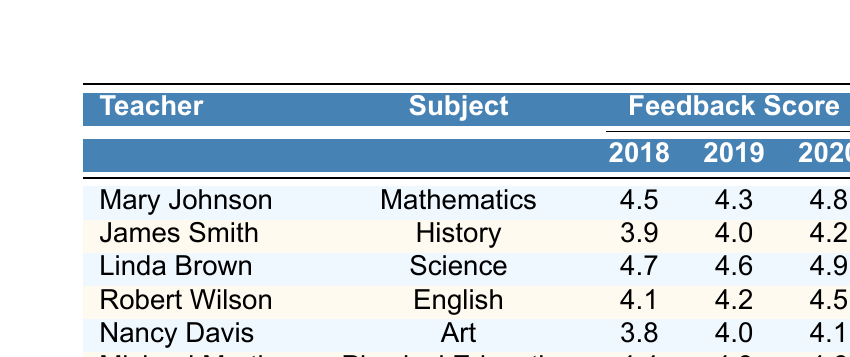What was the feedback score for Mary Johnson in 2019? In the row for Mary Johnson under the year 2019, the feedback score is listed as 4.3.
Answer: 4.3 Which teacher had the highest feedback score in 2020? Looking at the 2020 column, Mary Johnson has a score of 4.8, Linda Brown has 4.9, Robert Wilson has 4.5, Nancy Davis has 4.1, and Michael Martinez has 4.6. The highest score is 4.9 for Linda Brown.
Answer: Linda Brown What is the difference between Robert Wilson's 2018 and 2020 feedback scores? Robert Wilson's 2018 score is 4.1 and his 2020 score is 4.5. The difference is 4.5 - 4.1 = 0.4.
Answer: 0.4 What is the average feedback score for James Smith over the three years? The total scores for James Smith are 3.9 (2018) + 4.0 (2019) + 4.2 (2020) = 12.1. There are three years, so the average is 12.1 / 3 = 4.03333, which rounds to about 4.03.
Answer: 4.03 Did Nancy Davis receive a feedback score of 4.0 or higher in all three years? Nancy Davis's scores are 3.8 (2018), 4.0 (2019), and 4.1 (2020). She did not receive 4.0 or higher in 2018 and therefore does not meet the condition.
Answer: No Which subject had the highest average feedback score across all years? Calculating the averages: Mathematics (4.5 + 4.3 + 4.8)/3 = 4.53333, History (3.9 + 4.0 + 4.2)/3 = 4.03333, Science (4.7 + 4.6 + 4.9)/3 = 4.73333, English (4.1 + 4.2 + 4.5)/3 = 4.26667, Art (3.8 + 4.0 + 4.1)/3 = 3.96667, Physical Education (4.4 + 4.3 + 4.6)/3 = 4.43333. The highest average is 4.73333 for Science.
Answer: Science Whose feedback scores showed an increasing trend over the years? Analyzing each teacher's scores: Mary Johnson went from 4.5 to 4.3 to 4.8 (not increasing), James Smith went from 3.9 to 4.0 to 4.2 (increasing), Linda Brown went from 4.7 to 4.6 to 4.9 (not consistently increasing), Robert Wilson went from 4.1 to 4.2 to 4.5 (increasing), Nancy Davis went from 3.8 to 4.0 to 4.1 (increasing), and Michael Martinez went from 4.4 to 4.3 to 4.6 (not consistently increasing). Thus, James Smith, Robert Wilson, and Nancy Davis had increasing scores.
Answer: James Smith, Robert Wilson, Nancy Davis In which year did Michael Martinez have the lowest feedback score? Michael Martinez's scores are 4.4 (2018), 4.3 (2019), and 4.6 (2020). The lowest score was in 2019 with 4.3.
Answer: 2019 What was the total feedback score for all teachers in 2018? Summing the scores for 2018: Mary Johnson (4.5) + James Smith (3.9) + Linda Brown (4.7) + Robert Wilson (4.1) + Nancy Davis (3.8) + Michael Martinez (4.4) gives 4.5 + 3.9 + 4.7 + 4.1 + 3.8 + 4.4 = 25.4.
Answer: 25.4 Was Linda Brown always rated higher than Robert Wilson? Comparing scores across all years: 2018 (Linda 4.7 vs Robert 4.1), 2019 (Linda 4.6 vs Robert 4.2), and 2020 (Linda 4.9 vs Robert 4.5). Linda Brown was rated higher in all three years.
Answer: Yes 